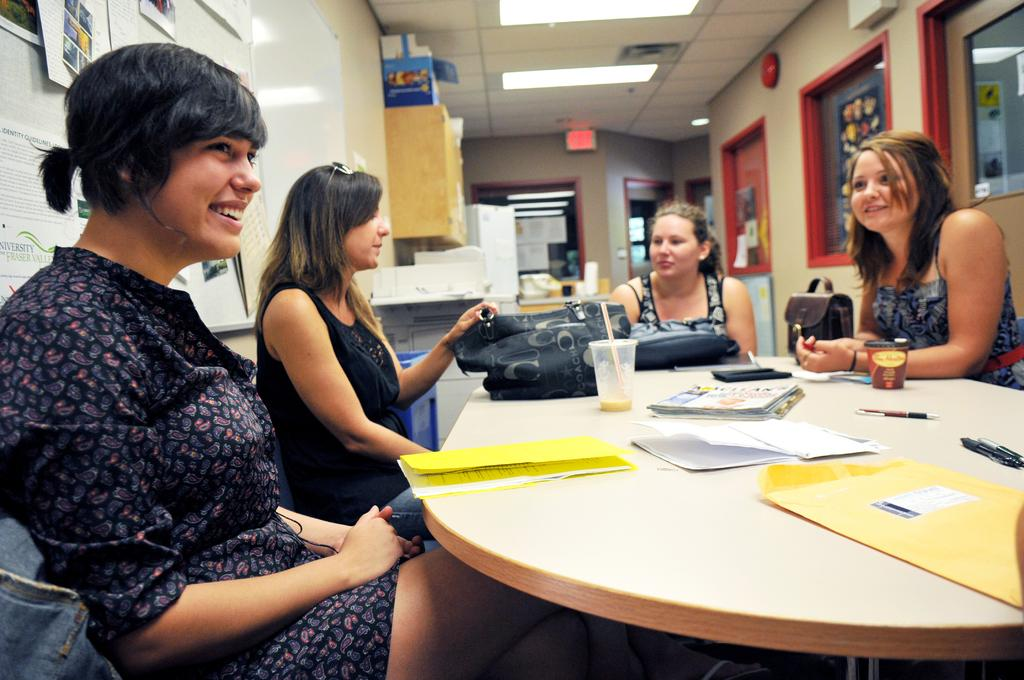How many people are present in the image? There are four women in the image. What are the women doing in the image? The women are sitting around a table. What objects can be seen on the table? There is a bag and papers on the table. What type of magic trick is being performed by the women in the image? There is no indication of a magic trick being performed in the image; the women are simply sitting around a table with a bag and papers. 